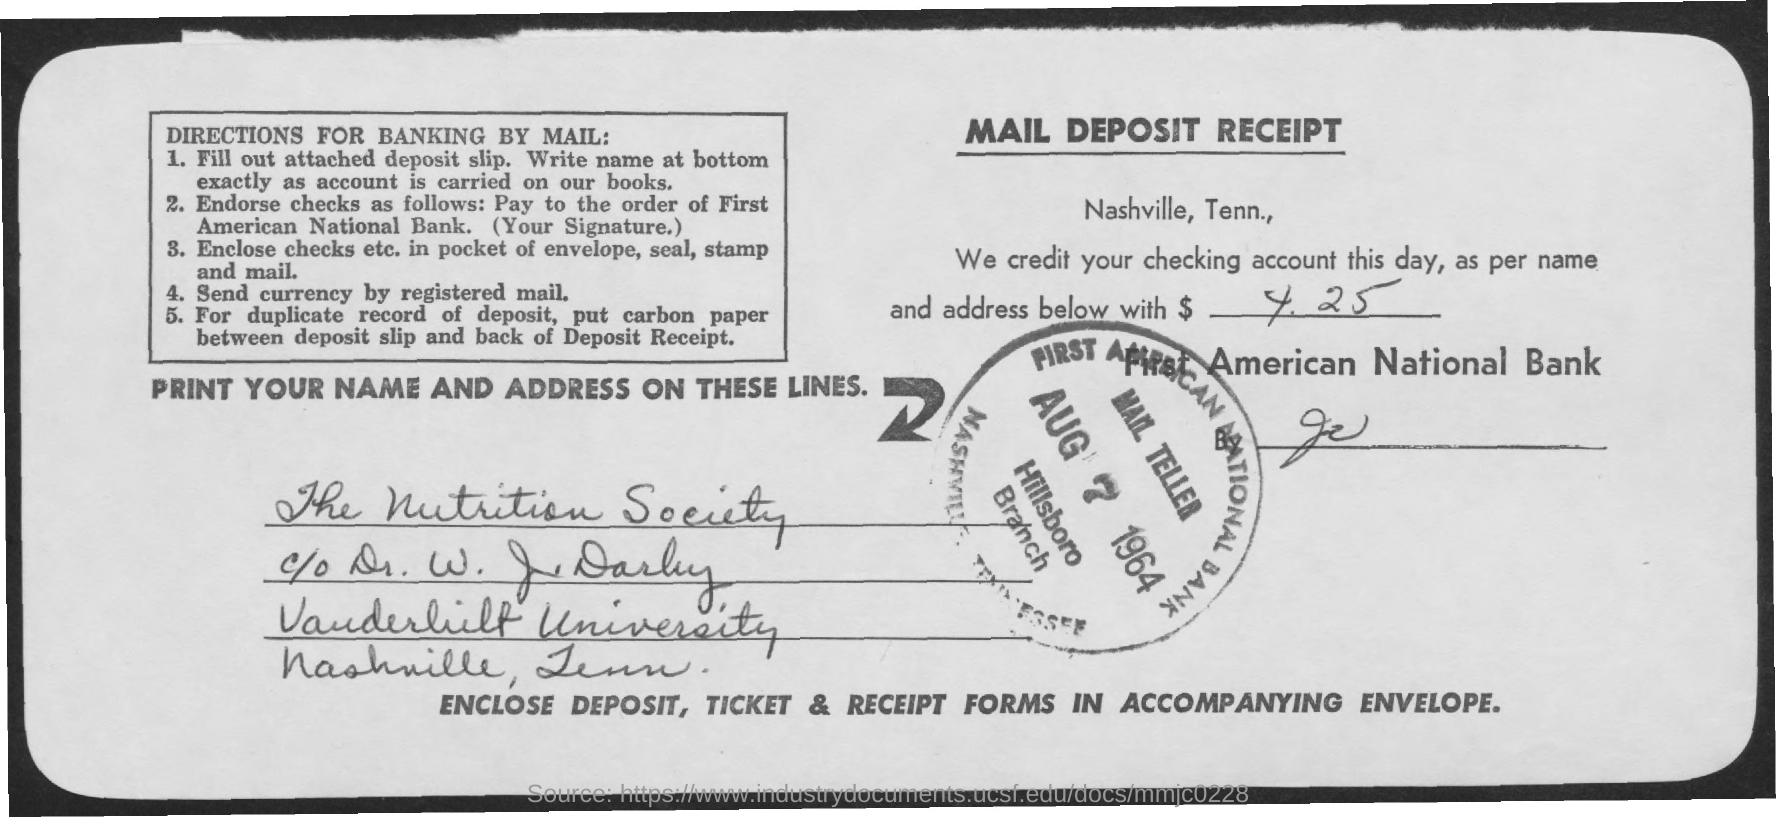What type of documentation is this?
Offer a very short reply. Mail deposit receipt. How much has been credited to the checking account?
Your response must be concise. $ 4.25. What is the date on the stamp?
Make the answer very short. AUG 7 1964. Which bank is mentioned?
Give a very brief answer. FIRST AMERICAN NATIONAL BANK. 